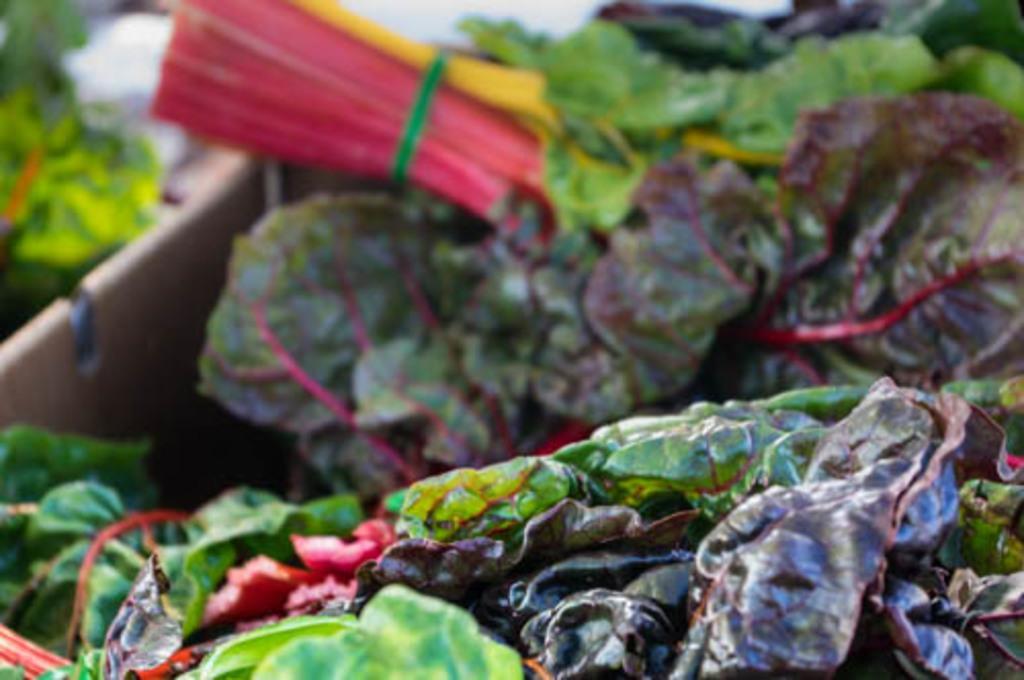Please provide a concise description of this image. In this image there are leaves, in the background it is blurred. 